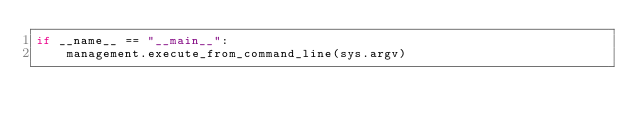<code> <loc_0><loc_0><loc_500><loc_500><_Python_>if __name__ == "__main__":
    management.execute_from_command_line(sys.argv)
</code> 